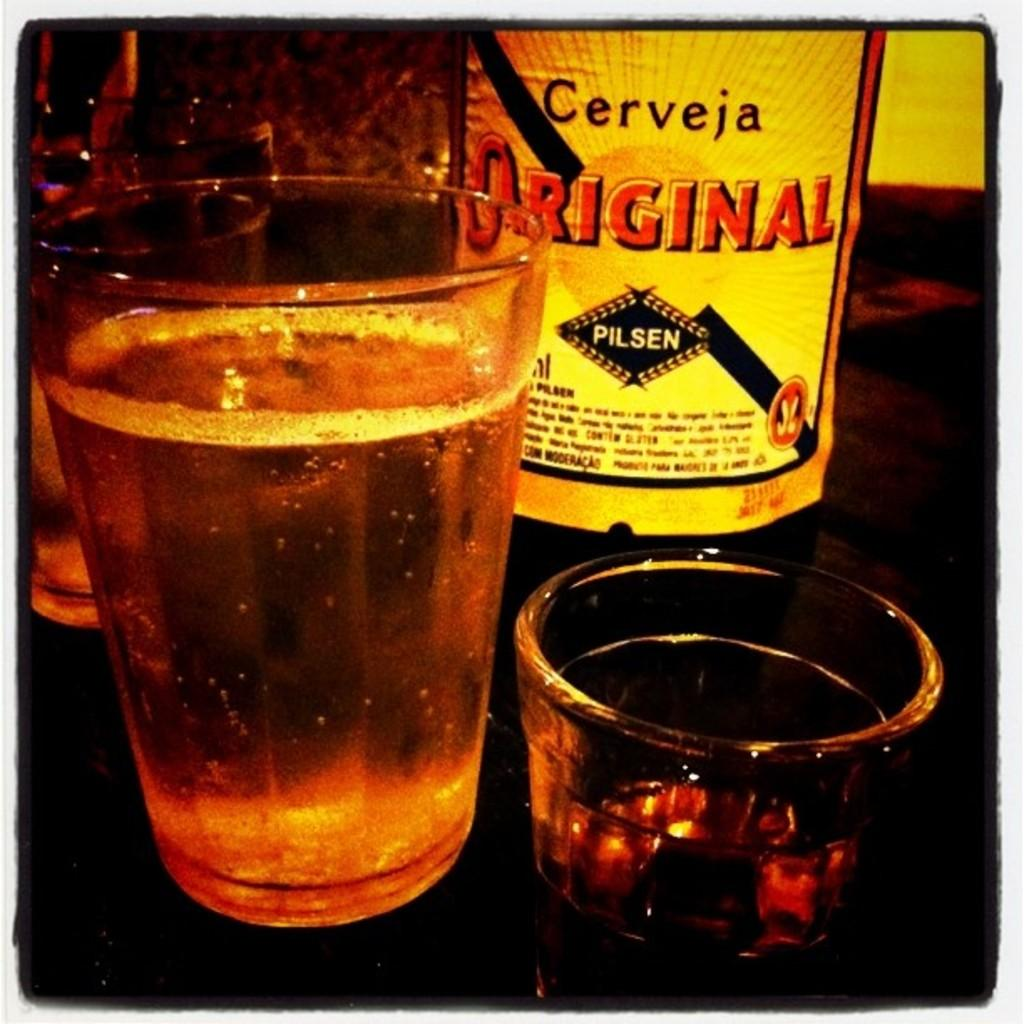<image>
Present a compact description of the photo's key features. bottle of cerveja original pilsen with a glassfull of it in front next to a shot glass 